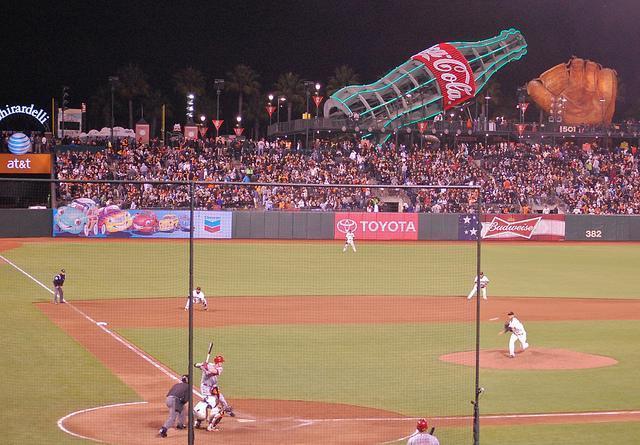How many stars in the Budweiser sign?
Give a very brief answer. 4. 